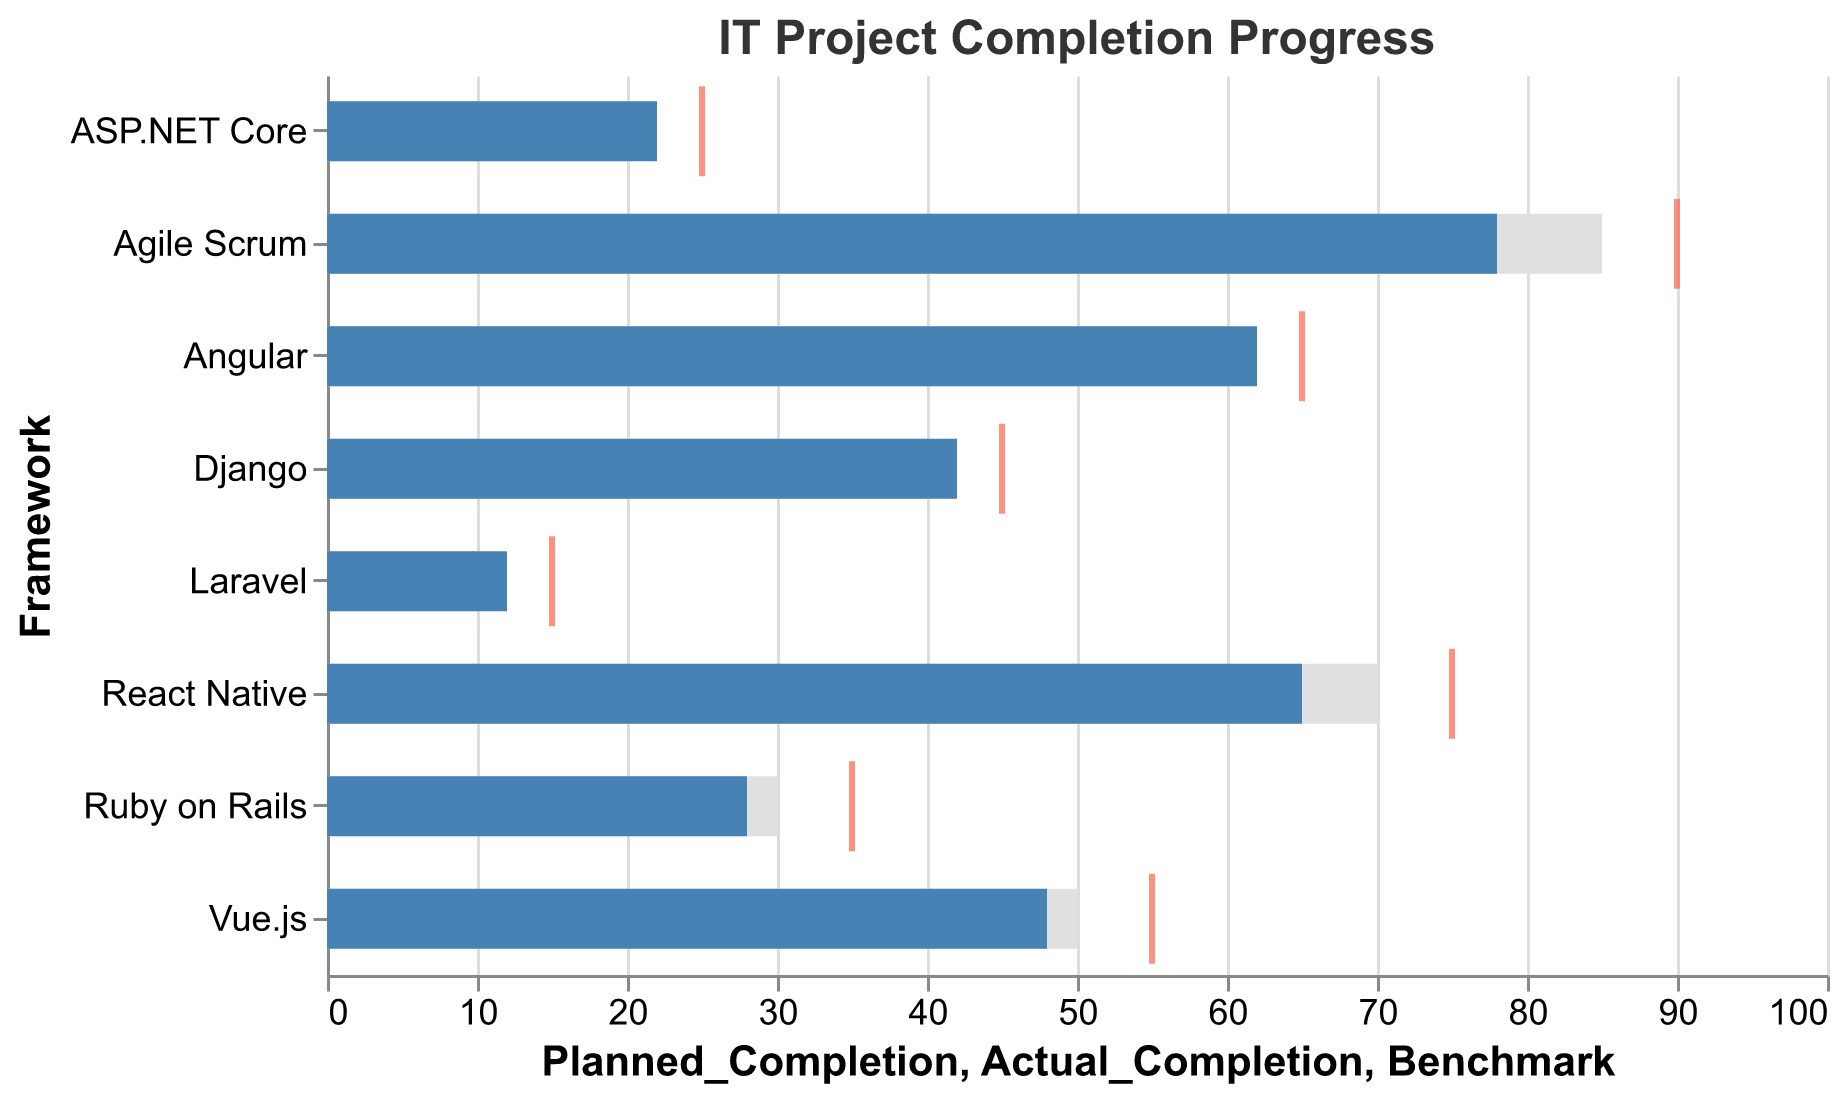What is the title of the chart? The title is located at the top of the chart and reads "IT Project Completion Progress".
Answer: IT Project Completion Progress Which framework has the highest planned completion percentage? By inspecting the lengths of the light gray bars, "Agile Scrum" has the longest bar with a planned completion of 85%.
Answer: Agile Scrum How much below the benchmark is React Native's actual completion? React Native's actual completion is 65%, and its benchmark is 75%. The difference is 75 - 65 = 10%.
Answer: 10% Which framework exceeded its planned completion percentage? By comparing the light gray and blue bars, the "Angular" framework has an actual completion (62%) that exceeds its planned completion (60%).
Answer: Angular What is the difference between planned and actual completion for Django? Django's planned completion is 40%, and its actual completion is 42%. The difference is 42 - 40 = 2%.
Answer: 2% Which framework has the smallest difference between planned and actual completion? By looking at the difference between the light gray and blue bars for each framework, Django has the smallest difference of 2%.
Answer: Django Is there any framework where the actual completion is below its benchmark? Yes, inspect the positions of the blue bars and red ticks for each framework. All frameworks have an actual completion below their benchmark according to the red tick marks.
Answer: Yes How does the actual completion of Vue.js compare to its planned completion and benchmark? Vue.js's planned completion is 50%, actual completion is 48%, and its benchmark is 55%. The actual completion is below both the planned completion and the benchmark by 2% and 7%, respectively.
Answer: Below both What is the average planned completion percentage across all frameworks? Summing all planned completion percentages: 85 + 70 + 60 + 50 + 40 + 30 + 20 + 10 = 365. Dividing by the number of frameworks (8): 365 / 8 = 45.625%.
Answer: 45.625% Which framework has the largest negative gap between planned and actual completion? By analyzing the differences, "Agile Scrum" has the largest negative gap as its actual completion of 78% is 7% below its planned completion of 85%.
Answer: Agile Scrum 